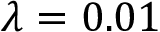Convert formula to latex. <formula><loc_0><loc_0><loc_500><loc_500>\lambda = 0 . 0 1</formula> 